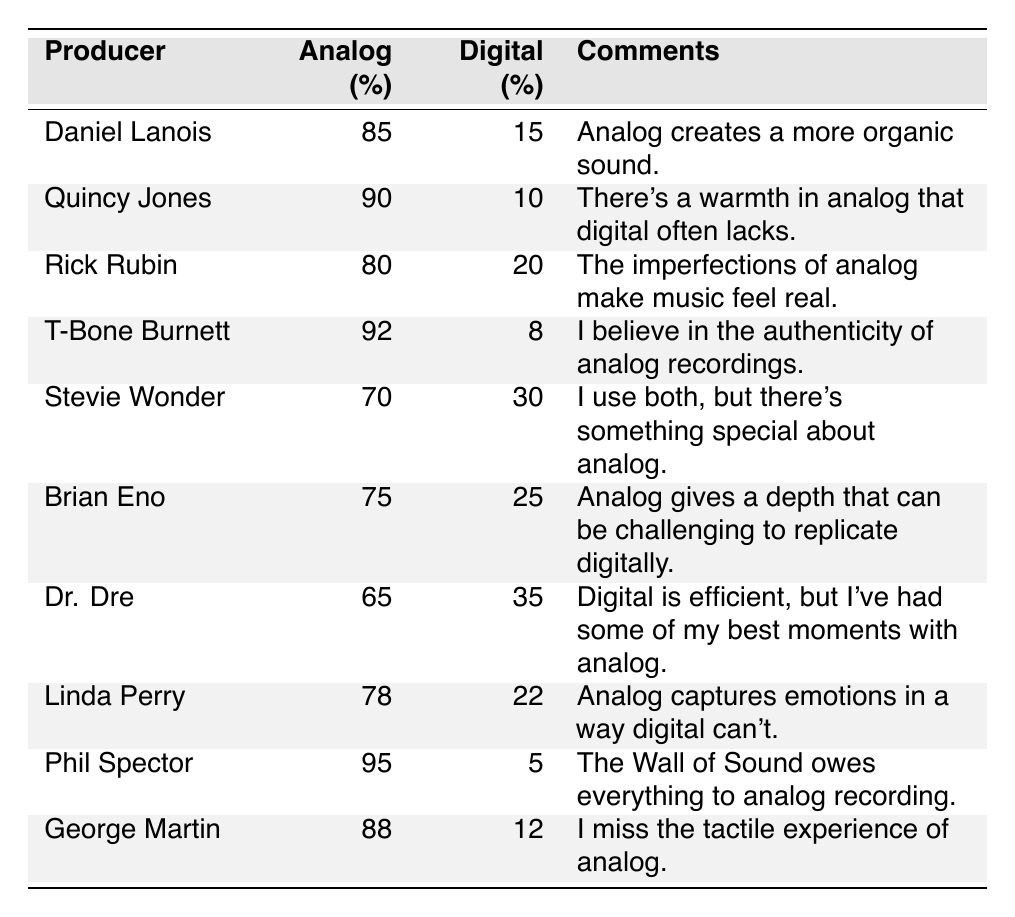What is the highest analog preference percentage among the producers? The highest analog preference percentage can be found by looking at the values in the Analog column. Phil Spector has the highest percentage at 95%.
Answer: 95% Which producer has the lowest digital preference percentage? To find the lowest digital preference, identify the smallest value in the Digital column. T-Bone Burnett has the lowest digital preference at 8%.
Answer: 8% What is the average analog preference percentage across all producers? To calculate the average, sum all the analog preferences: (85 + 90 + 80 + 92 + 70 + 75 + 65 + 78 + 95 + 88) = 820. There are 10 producers, so the average is 820 / 10 = 82%.
Answer: 82% Is there any producer who prefers analog recording more than 90%? By reviewing the Analog column, T-Bone Burnett and Phil Spector both have analog preferences greater than 90%. Therefore, the answer is yes.
Answer: Yes Which producer's comments emphasize the warmth of analog recording? Quincy Jones mentions "a warmth in analog" in his comments. Checking the Comments column confirms this.
Answer: Quincy Jones What is the total percentage preference for digital recording across all producers? To find the total for digital, sum all digital preferences: (15 + 10 + 20 + 8 + 30 + 25 + 35 + 22 + 5 + 12) = 177%.
Answer: 177% How many producers have an analog preference below 75%? Check the Analog column for values below 75%. The only producer is Dr. Dre with 65%. Hence, there is one producer below 75%.
Answer: 1 What is the difference between the highest and lowest analog preferences? Identify the highest analog preference (95% from Phil Spector) and the lowest (65% from Dr. Dre). The difference is 95% - 65% = 30%.
Answer: 30% Do any producers' comments suggest that they use both methods of recording? Stevie Wonder specifically mentions using both analog and digital methods in his comments.
Answer: Yes Which producer has a higher digital preference: Dr. Dre or Brian Eno? Compare the digital preferences: Dr. Dre has 35% and Brian Eno has 25%. Since 35% is greater than 25%, Dr. Dre has a higher digital preference.
Answer: Dr. Dre 